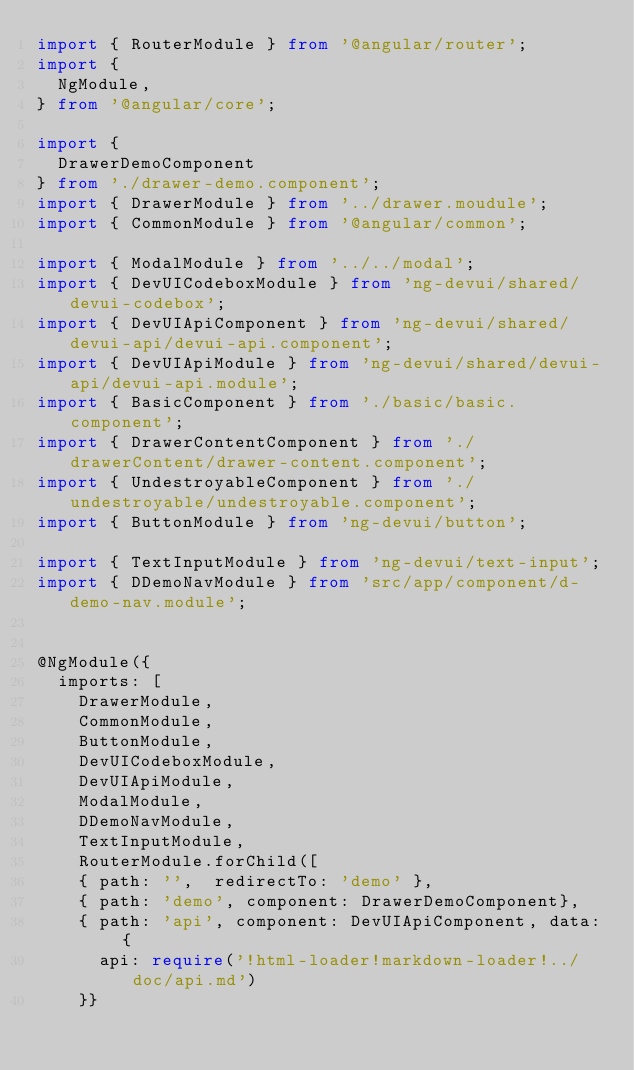<code> <loc_0><loc_0><loc_500><loc_500><_TypeScript_>import { RouterModule } from '@angular/router';
import {
  NgModule,
} from '@angular/core';

import {
  DrawerDemoComponent
} from './drawer-demo.component';
import { DrawerModule } from '../drawer.moudule';
import { CommonModule } from '@angular/common';

import { ModalModule } from '../../modal';
import { DevUICodeboxModule } from 'ng-devui/shared/devui-codebox';
import { DevUIApiComponent } from 'ng-devui/shared/devui-api/devui-api.component';
import { DevUIApiModule } from 'ng-devui/shared/devui-api/devui-api.module';
import { BasicComponent } from './basic/basic.component';
import { DrawerContentComponent } from './drawerContent/drawer-content.component';
import { UndestroyableComponent } from './undestroyable/undestroyable.component';
import { ButtonModule } from 'ng-devui/button';

import { TextInputModule } from 'ng-devui/text-input';
import { DDemoNavModule } from 'src/app/component/d-demo-nav.module';


@NgModule({
  imports: [
    DrawerModule,
    CommonModule,
    ButtonModule,
    DevUICodeboxModule,
    DevUIApiModule,
    ModalModule,
    DDemoNavModule,
    TextInputModule,
    RouterModule.forChild([
    { path: '',  redirectTo: 'demo' },
    { path: 'demo', component: DrawerDemoComponent},
    { path: 'api', component: DevUIApiComponent, data: {
      api: require('!html-loader!markdown-loader!../doc/api.md')
    }}</code> 